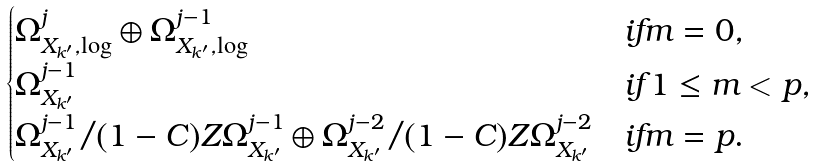<formula> <loc_0><loc_0><loc_500><loc_500>\begin{cases} \Omega ^ { j } _ { X _ { k ^ { \prime } } , \log } \oplus \Omega ^ { j - 1 } _ { X _ { k ^ { \prime } } , \log } & i f m = 0 , \\ \Omega ^ { j - 1 } _ { X _ { k ^ { \prime } } } & i f 1 \leq m < p , \\ \Omega ^ { j - 1 } _ { X _ { k ^ { \prime } } } / ( 1 - C ) Z \Omega ^ { j - 1 } _ { X _ { k ^ { \prime } } } \oplus \Omega ^ { j - 2 } _ { X _ { k ^ { \prime } } } / ( 1 - C ) Z \Omega ^ { j - 2 } _ { X _ { k ^ { \prime } } } & i f m = p . \end{cases}</formula> 